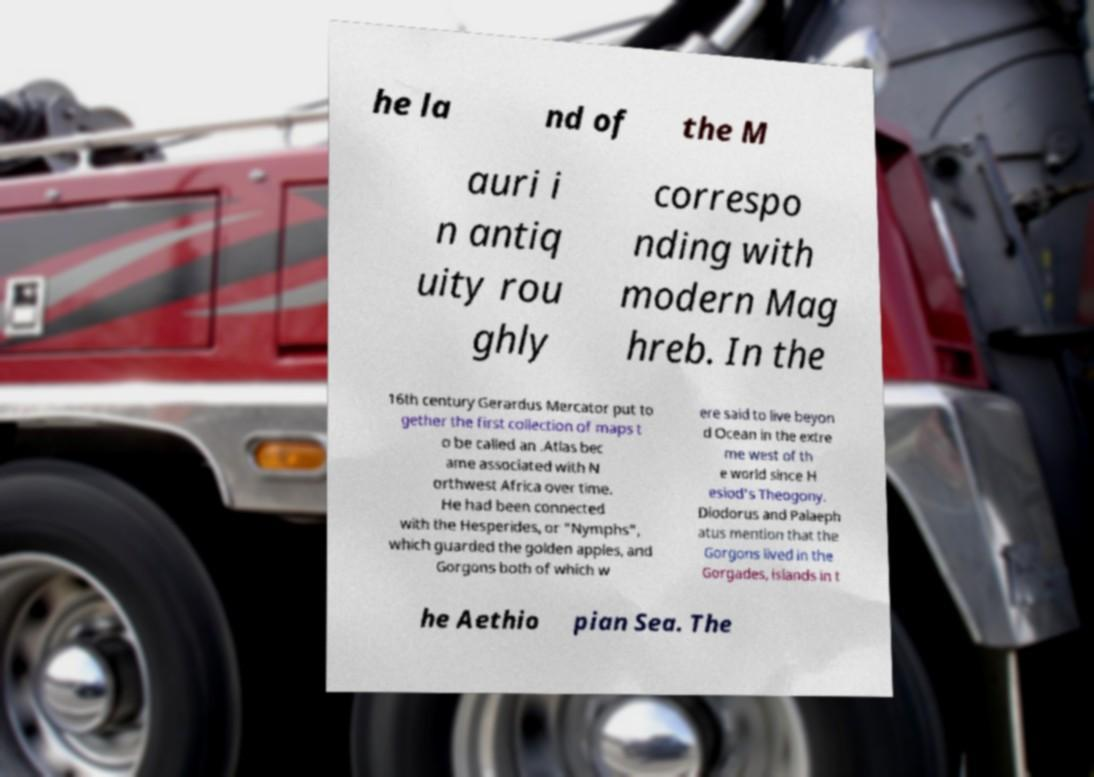Could you assist in decoding the text presented in this image and type it out clearly? he la nd of the M auri i n antiq uity rou ghly correspo nding with modern Mag hreb. In the 16th century Gerardus Mercator put to gether the first collection of maps t o be called an .Atlas bec ame associated with N orthwest Africa over time. He had been connected with the Hesperides, or "Nymphs", which guarded the golden apples, and Gorgons both of which w ere said to live beyon d Ocean in the extre me west of th e world since H esiod's Theogony. Diodorus and Palaeph atus mention that the Gorgons lived in the Gorgades, islands in t he Aethio pian Sea. The 